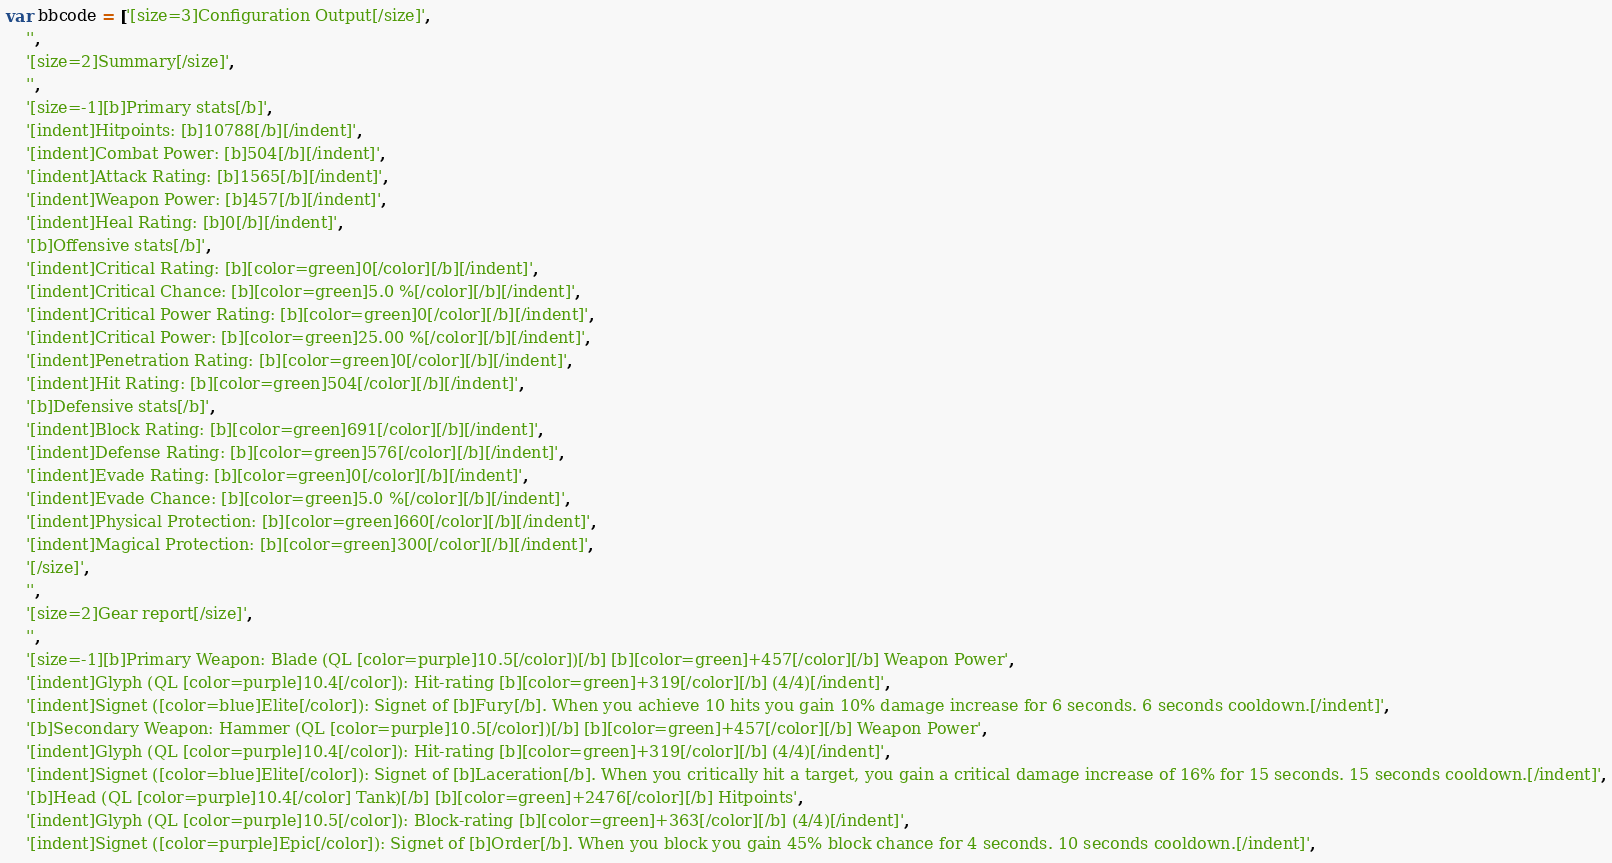Convert code to text. <code><loc_0><loc_0><loc_500><loc_500><_JavaScript_>var bbcode = ['[size=3]Configuration Output[/size]',
    '',
    '[size=2]Summary[/size]',
    '',
    '[size=-1][b]Primary stats[/b]',
    '[indent]Hitpoints: [b]10788[/b][/indent]',
    '[indent]Combat Power: [b]504[/b][/indent]',
    '[indent]Attack Rating: [b]1565[/b][/indent]',
    '[indent]Weapon Power: [b]457[/b][/indent]',
    '[indent]Heal Rating: [b]0[/b][/indent]',
    '[b]Offensive stats[/b]',
    '[indent]Critical Rating: [b][color=green]0[/color][/b][/indent]',
    '[indent]Critical Chance: [b][color=green]5.0 %[/color][/b][/indent]',
    '[indent]Critical Power Rating: [b][color=green]0[/color][/b][/indent]',
    '[indent]Critical Power: [b][color=green]25.00 %[/color][/b][/indent]',
    '[indent]Penetration Rating: [b][color=green]0[/color][/b][/indent]',
    '[indent]Hit Rating: [b][color=green]504[/color][/b][/indent]',
    '[b]Defensive stats[/b]',
    '[indent]Block Rating: [b][color=green]691[/color][/b][/indent]',
    '[indent]Defense Rating: [b][color=green]576[/color][/b][/indent]',
    '[indent]Evade Rating: [b][color=green]0[/color][/b][/indent]',
    '[indent]Evade Chance: [b][color=green]5.0 %[/color][/b][/indent]',
    '[indent]Physical Protection: [b][color=green]660[/color][/b][/indent]',
    '[indent]Magical Protection: [b][color=green]300[/color][/b][/indent]',
    '[/size]',
    '',
    '[size=2]Gear report[/size]',
    '',
    '[size=-1][b]Primary Weapon: Blade (QL [color=purple]10.5[/color])[/b] [b][color=green]+457[/color][/b] Weapon Power',
    '[indent]Glyph (QL [color=purple]10.4[/color]): Hit-rating [b][color=green]+319[/color][/b] (4/4)[/indent]',
    '[indent]Signet ([color=blue]Elite[/color]): Signet of [b]Fury[/b]. When you achieve 10 hits you gain 10% damage increase for 6 seconds. 6 seconds cooldown.[/indent]',
    '[b]Secondary Weapon: Hammer (QL [color=purple]10.5[/color])[/b] [b][color=green]+457[/color][/b] Weapon Power',
    '[indent]Glyph (QL [color=purple]10.4[/color]): Hit-rating [b][color=green]+319[/color][/b] (4/4)[/indent]',
    '[indent]Signet ([color=blue]Elite[/color]): Signet of [b]Laceration[/b]. When you critically hit a target, you gain a critical damage increase of 16% for 15 seconds. 15 seconds cooldown.[/indent]',
    '[b]Head (QL [color=purple]10.4[/color] Tank)[/b] [b][color=green]+2476[/color][/b] Hitpoints',
    '[indent]Glyph (QL [color=purple]10.5[/color]): Block-rating [b][color=green]+363[/color][/b] (4/4)[/indent]',
    '[indent]Signet ([color=purple]Epic[/color]): Signet of [b]Order[/b]. When you block you gain 45% block chance for 4 seconds. 10 seconds cooldown.[/indent]',</code> 